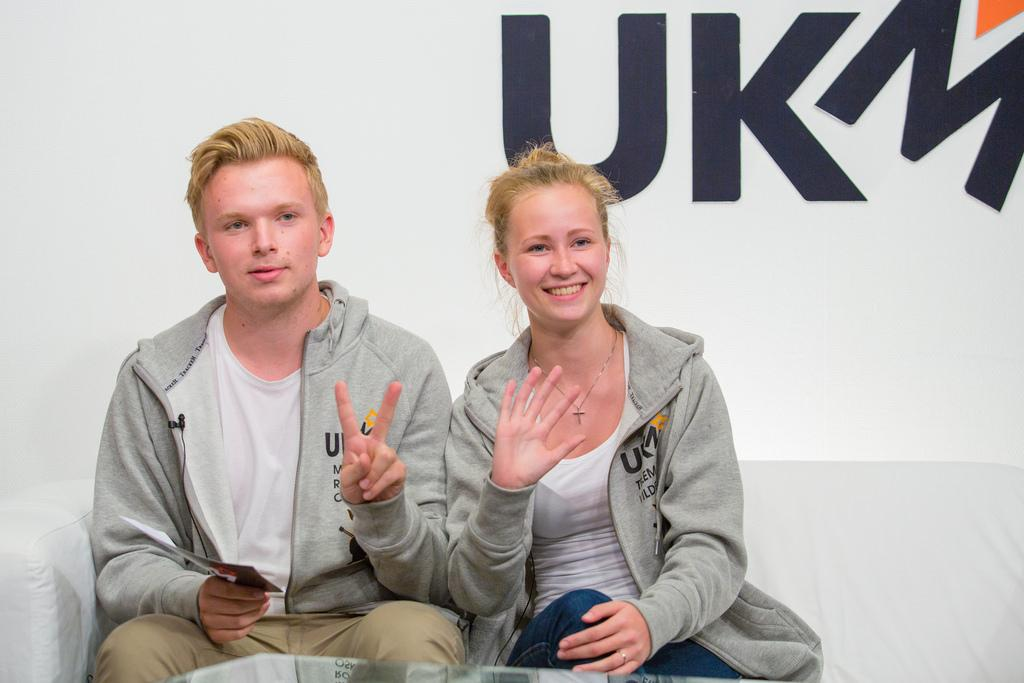Who is present in the image? There is a couple in the image. What are they wearing? The couple is wearing the same jacket. Where are they sitting? The couple is sitting on a sofa. What can be seen in the background of the image? The letters "ukm" are visible in the background of the image. What type of coil is being used by the couple in the image? There is no coil present in the image. What season is depicted in the image? The image does not indicate a specific season, as there are no seasonal cues present. 